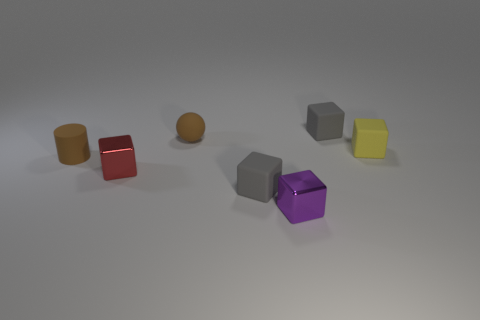Subtract all gray cubes. How many cubes are left? 3 Add 2 brown spheres. How many objects exist? 9 Subtract all cylinders. How many objects are left? 6 Add 1 small metallic objects. How many small metallic objects exist? 3 Subtract all yellow blocks. How many blocks are left? 4 Subtract 0 cyan cylinders. How many objects are left? 7 Subtract all red blocks. Subtract all brown cylinders. How many blocks are left? 4 Subtract all cyan spheres. How many red blocks are left? 1 Subtract all tiny rubber blocks. Subtract all tiny matte blocks. How many objects are left? 1 Add 7 red metallic cubes. How many red metallic cubes are left? 8 